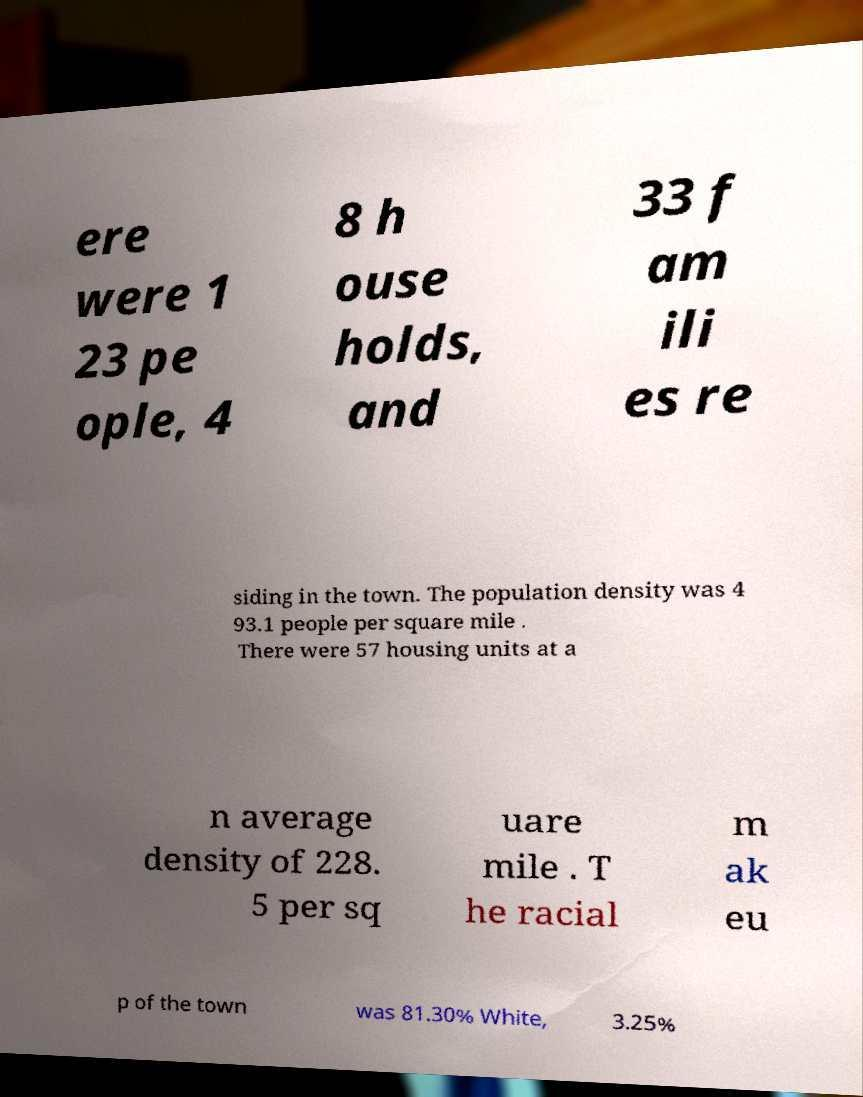For documentation purposes, I need the text within this image transcribed. Could you provide that? ere were 1 23 pe ople, 4 8 h ouse holds, and 33 f am ili es re siding in the town. The population density was 4 93.1 people per square mile . There were 57 housing units at a n average density of 228. 5 per sq uare mile . T he racial m ak eu p of the town was 81.30% White, 3.25% 